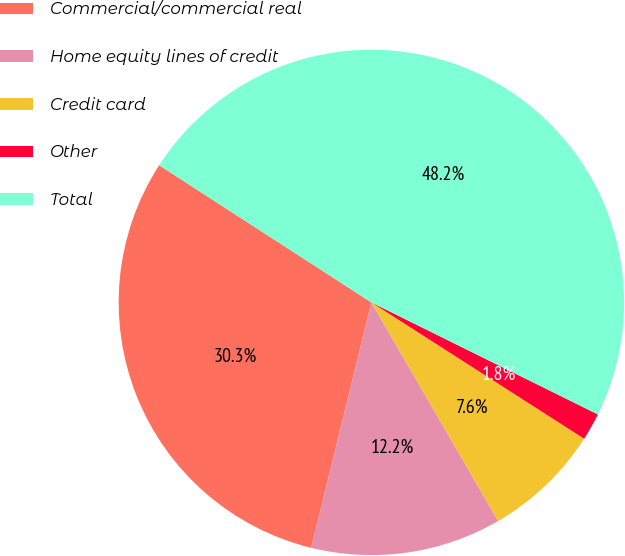Convert chart to OTSL. <chart><loc_0><loc_0><loc_500><loc_500><pie_chart><fcel>Commercial/commercial real<fcel>Home equity lines of credit<fcel>Credit card<fcel>Other<fcel>Total<nl><fcel>30.3%<fcel>12.2%<fcel>7.56%<fcel>1.76%<fcel>48.17%<nl></chart> 